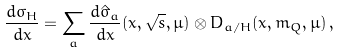<formula> <loc_0><loc_0><loc_500><loc_500>\frac { d \sigma _ { H } } { d x } = \sum _ { a } \frac { d \hat { \sigma } _ { a } } { d x } ( x , \sqrt { s } , \mu ) \otimes D _ { a / H } ( x , m _ { Q } , \mu ) \, ,</formula> 